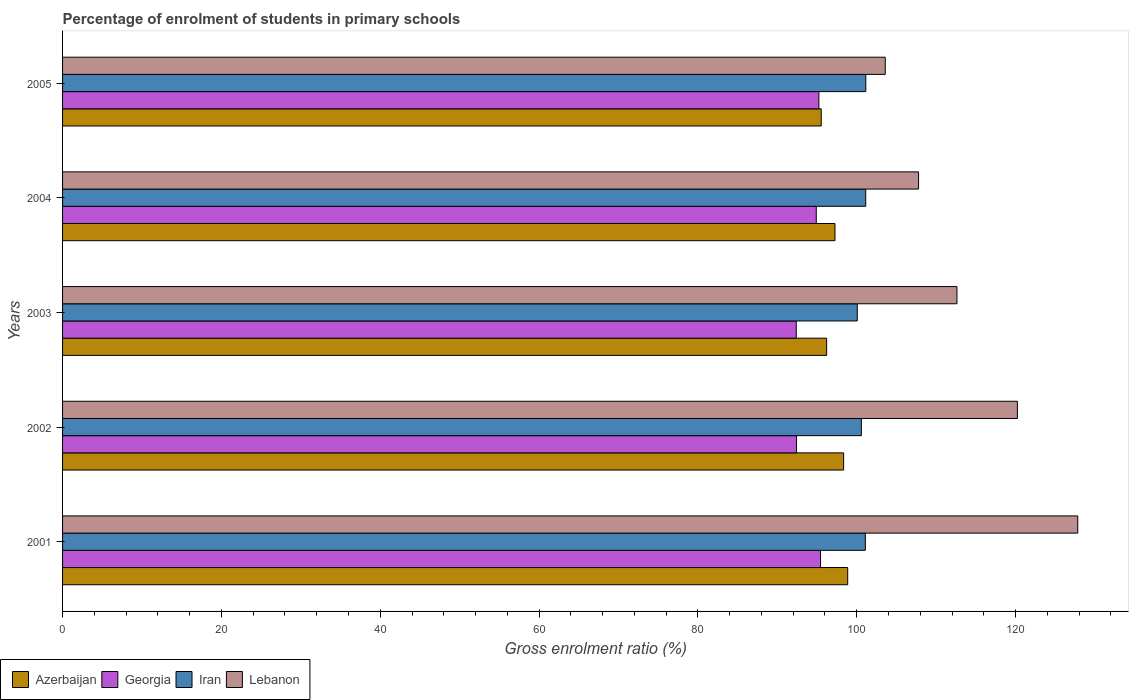How many different coloured bars are there?
Give a very brief answer. 4. Are the number of bars on each tick of the Y-axis equal?
Offer a very short reply. Yes. How many bars are there on the 1st tick from the top?
Make the answer very short. 4. What is the percentage of students enrolled in primary schools in Azerbaijan in 2005?
Your answer should be compact. 95.53. Across all years, what is the maximum percentage of students enrolled in primary schools in Georgia?
Offer a terse response. 95.44. Across all years, what is the minimum percentage of students enrolled in primary schools in Azerbaijan?
Offer a very short reply. 95.53. What is the total percentage of students enrolled in primary schools in Georgia in the graph?
Offer a terse response. 470.38. What is the difference between the percentage of students enrolled in primary schools in Georgia in 2001 and that in 2004?
Offer a very short reply. 0.54. What is the difference between the percentage of students enrolled in primary schools in Lebanon in 2004 and the percentage of students enrolled in primary schools in Georgia in 2001?
Your answer should be very brief. 12.35. What is the average percentage of students enrolled in primary schools in Lebanon per year?
Ensure brevity in your answer.  114.41. In the year 2004, what is the difference between the percentage of students enrolled in primary schools in Lebanon and percentage of students enrolled in primary schools in Iran?
Your answer should be compact. 6.65. What is the ratio of the percentage of students enrolled in primary schools in Iran in 2002 to that in 2004?
Ensure brevity in your answer.  0.99. What is the difference between the highest and the second highest percentage of students enrolled in primary schools in Lebanon?
Offer a terse response. 7.6. What is the difference between the highest and the lowest percentage of students enrolled in primary schools in Georgia?
Make the answer very short. 3.06. In how many years, is the percentage of students enrolled in primary schools in Iran greater than the average percentage of students enrolled in primary schools in Iran taken over all years?
Give a very brief answer. 3. What does the 3rd bar from the top in 2003 represents?
Provide a succinct answer. Georgia. What does the 2nd bar from the bottom in 2002 represents?
Your answer should be compact. Georgia. Is it the case that in every year, the sum of the percentage of students enrolled in primary schools in Lebanon and percentage of students enrolled in primary schools in Azerbaijan is greater than the percentage of students enrolled in primary schools in Georgia?
Your answer should be very brief. Yes. How many bars are there?
Offer a very short reply. 20. What is the difference between two consecutive major ticks on the X-axis?
Offer a terse response. 20. Are the values on the major ticks of X-axis written in scientific E-notation?
Your response must be concise. No. What is the title of the graph?
Give a very brief answer. Percentage of enrolment of students in primary schools. Does "East Asia (developing only)" appear as one of the legend labels in the graph?
Your response must be concise. No. What is the label or title of the Y-axis?
Provide a short and direct response. Years. What is the Gross enrolment ratio (%) of Azerbaijan in 2001?
Make the answer very short. 98.86. What is the Gross enrolment ratio (%) in Georgia in 2001?
Offer a very short reply. 95.44. What is the Gross enrolment ratio (%) in Iran in 2001?
Make the answer very short. 101.08. What is the Gross enrolment ratio (%) in Lebanon in 2001?
Offer a terse response. 127.83. What is the Gross enrolment ratio (%) in Azerbaijan in 2002?
Provide a succinct answer. 98.35. What is the Gross enrolment ratio (%) of Georgia in 2002?
Make the answer very short. 92.42. What is the Gross enrolment ratio (%) in Iran in 2002?
Keep it short and to the point. 100.58. What is the Gross enrolment ratio (%) in Lebanon in 2002?
Your answer should be very brief. 120.23. What is the Gross enrolment ratio (%) of Azerbaijan in 2003?
Offer a terse response. 96.21. What is the Gross enrolment ratio (%) of Georgia in 2003?
Make the answer very short. 92.38. What is the Gross enrolment ratio (%) in Iran in 2003?
Offer a very short reply. 100.07. What is the Gross enrolment ratio (%) in Lebanon in 2003?
Your answer should be compact. 112.62. What is the Gross enrolment ratio (%) in Azerbaijan in 2004?
Provide a succinct answer. 97.26. What is the Gross enrolment ratio (%) of Georgia in 2004?
Your response must be concise. 94.9. What is the Gross enrolment ratio (%) in Iran in 2004?
Offer a terse response. 101.13. What is the Gross enrolment ratio (%) in Lebanon in 2004?
Give a very brief answer. 107.79. What is the Gross enrolment ratio (%) of Azerbaijan in 2005?
Provide a short and direct response. 95.53. What is the Gross enrolment ratio (%) in Georgia in 2005?
Your response must be concise. 95.23. What is the Gross enrolment ratio (%) of Iran in 2005?
Your answer should be compact. 101.14. What is the Gross enrolment ratio (%) of Lebanon in 2005?
Give a very brief answer. 103.59. Across all years, what is the maximum Gross enrolment ratio (%) in Azerbaijan?
Keep it short and to the point. 98.86. Across all years, what is the maximum Gross enrolment ratio (%) of Georgia?
Keep it short and to the point. 95.44. Across all years, what is the maximum Gross enrolment ratio (%) in Iran?
Your answer should be very brief. 101.14. Across all years, what is the maximum Gross enrolment ratio (%) of Lebanon?
Ensure brevity in your answer.  127.83. Across all years, what is the minimum Gross enrolment ratio (%) in Azerbaijan?
Make the answer very short. 95.53. Across all years, what is the minimum Gross enrolment ratio (%) in Georgia?
Offer a terse response. 92.38. Across all years, what is the minimum Gross enrolment ratio (%) of Iran?
Provide a short and direct response. 100.07. Across all years, what is the minimum Gross enrolment ratio (%) in Lebanon?
Ensure brevity in your answer.  103.59. What is the total Gross enrolment ratio (%) in Azerbaijan in the graph?
Make the answer very short. 486.21. What is the total Gross enrolment ratio (%) in Georgia in the graph?
Provide a short and direct response. 470.38. What is the total Gross enrolment ratio (%) of Iran in the graph?
Ensure brevity in your answer.  504.01. What is the total Gross enrolment ratio (%) of Lebanon in the graph?
Give a very brief answer. 572.05. What is the difference between the Gross enrolment ratio (%) in Azerbaijan in 2001 and that in 2002?
Your answer should be very brief. 0.51. What is the difference between the Gross enrolment ratio (%) of Georgia in 2001 and that in 2002?
Your answer should be compact. 3.02. What is the difference between the Gross enrolment ratio (%) in Iran in 2001 and that in 2002?
Your answer should be very brief. 0.5. What is the difference between the Gross enrolment ratio (%) of Lebanon in 2001 and that in 2002?
Offer a terse response. 7.6. What is the difference between the Gross enrolment ratio (%) in Azerbaijan in 2001 and that in 2003?
Give a very brief answer. 2.65. What is the difference between the Gross enrolment ratio (%) in Georgia in 2001 and that in 2003?
Your answer should be very brief. 3.06. What is the difference between the Gross enrolment ratio (%) in Iran in 2001 and that in 2003?
Provide a short and direct response. 1.02. What is the difference between the Gross enrolment ratio (%) in Lebanon in 2001 and that in 2003?
Your answer should be compact. 15.21. What is the difference between the Gross enrolment ratio (%) in Azerbaijan in 2001 and that in 2004?
Your answer should be compact. 1.6. What is the difference between the Gross enrolment ratio (%) in Georgia in 2001 and that in 2004?
Keep it short and to the point. 0.54. What is the difference between the Gross enrolment ratio (%) in Iran in 2001 and that in 2004?
Your answer should be very brief. -0.05. What is the difference between the Gross enrolment ratio (%) in Lebanon in 2001 and that in 2004?
Offer a very short reply. 20.04. What is the difference between the Gross enrolment ratio (%) of Azerbaijan in 2001 and that in 2005?
Provide a short and direct response. 3.33. What is the difference between the Gross enrolment ratio (%) of Georgia in 2001 and that in 2005?
Your answer should be very brief. 0.21. What is the difference between the Gross enrolment ratio (%) of Iran in 2001 and that in 2005?
Offer a terse response. -0.05. What is the difference between the Gross enrolment ratio (%) in Lebanon in 2001 and that in 2005?
Your answer should be very brief. 24.24. What is the difference between the Gross enrolment ratio (%) of Azerbaijan in 2002 and that in 2003?
Your answer should be very brief. 2.14. What is the difference between the Gross enrolment ratio (%) of Georgia in 2002 and that in 2003?
Keep it short and to the point. 0.04. What is the difference between the Gross enrolment ratio (%) of Iran in 2002 and that in 2003?
Keep it short and to the point. 0.51. What is the difference between the Gross enrolment ratio (%) of Lebanon in 2002 and that in 2003?
Your answer should be very brief. 7.61. What is the difference between the Gross enrolment ratio (%) in Azerbaijan in 2002 and that in 2004?
Provide a succinct answer. 1.09. What is the difference between the Gross enrolment ratio (%) of Georgia in 2002 and that in 2004?
Your answer should be very brief. -2.48. What is the difference between the Gross enrolment ratio (%) of Iran in 2002 and that in 2004?
Give a very brief answer. -0.55. What is the difference between the Gross enrolment ratio (%) in Lebanon in 2002 and that in 2004?
Your response must be concise. 12.45. What is the difference between the Gross enrolment ratio (%) in Azerbaijan in 2002 and that in 2005?
Your answer should be compact. 2.82. What is the difference between the Gross enrolment ratio (%) of Georgia in 2002 and that in 2005?
Your response must be concise. -2.81. What is the difference between the Gross enrolment ratio (%) in Iran in 2002 and that in 2005?
Ensure brevity in your answer.  -0.56. What is the difference between the Gross enrolment ratio (%) of Lebanon in 2002 and that in 2005?
Provide a succinct answer. 16.64. What is the difference between the Gross enrolment ratio (%) in Azerbaijan in 2003 and that in 2004?
Your response must be concise. -1.05. What is the difference between the Gross enrolment ratio (%) of Georgia in 2003 and that in 2004?
Your answer should be compact. -2.52. What is the difference between the Gross enrolment ratio (%) in Iran in 2003 and that in 2004?
Your answer should be very brief. -1.06. What is the difference between the Gross enrolment ratio (%) of Lebanon in 2003 and that in 2004?
Keep it short and to the point. 4.83. What is the difference between the Gross enrolment ratio (%) in Azerbaijan in 2003 and that in 2005?
Offer a very short reply. 0.69. What is the difference between the Gross enrolment ratio (%) in Georgia in 2003 and that in 2005?
Keep it short and to the point. -2.85. What is the difference between the Gross enrolment ratio (%) in Iran in 2003 and that in 2005?
Ensure brevity in your answer.  -1.07. What is the difference between the Gross enrolment ratio (%) in Lebanon in 2003 and that in 2005?
Your answer should be compact. 9.03. What is the difference between the Gross enrolment ratio (%) in Azerbaijan in 2004 and that in 2005?
Give a very brief answer. 1.73. What is the difference between the Gross enrolment ratio (%) in Georgia in 2004 and that in 2005?
Make the answer very short. -0.33. What is the difference between the Gross enrolment ratio (%) in Iran in 2004 and that in 2005?
Offer a very short reply. -0.01. What is the difference between the Gross enrolment ratio (%) of Lebanon in 2004 and that in 2005?
Your response must be concise. 4.19. What is the difference between the Gross enrolment ratio (%) in Azerbaijan in 2001 and the Gross enrolment ratio (%) in Georgia in 2002?
Give a very brief answer. 6.44. What is the difference between the Gross enrolment ratio (%) in Azerbaijan in 2001 and the Gross enrolment ratio (%) in Iran in 2002?
Offer a very short reply. -1.72. What is the difference between the Gross enrolment ratio (%) of Azerbaijan in 2001 and the Gross enrolment ratio (%) of Lebanon in 2002?
Ensure brevity in your answer.  -21.37. What is the difference between the Gross enrolment ratio (%) of Georgia in 2001 and the Gross enrolment ratio (%) of Iran in 2002?
Your response must be concise. -5.14. What is the difference between the Gross enrolment ratio (%) of Georgia in 2001 and the Gross enrolment ratio (%) of Lebanon in 2002?
Keep it short and to the point. -24.79. What is the difference between the Gross enrolment ratio (%) of Iran in 2001 and the Gross enrolment ratio (%) of Lebanon in 2002?
Offer a very short reply. -19.15. What is the difference between the Gross enrolment ratio (%) in Azerbaijan in 2001 and the Gross enrolment ratio (%) in Georgia in 2003?
Your response must be concise. 6.48. What is the difference between the Gross enrolment ratio (%) of Azerbaijan in 2001 and the Gross enrolment ratio (%) of Iran in 2003?
Your answer should be very brief. -1.21. What is the difference between the Gross enrolment ratio (%) in Azerbaijan in 2001 and the Gross enrolment ratio (%) in Lebanon in 2003?
Make the answer very short. -13.76. What is the difference between the Gross enrolment ratio (%) of Georgia in 2001 and the Gross enrolment ratio (%) of Iran in 2003?
Your answer should be very brief. -4.63. What is the difference between the Gross enrolment ratio (%) of Georgia in 2001 and the Gross enrolment ratio (%) of Lebanon in 2003?
Keep it short and to the point. -17.18. What is the difference between the Gross enrolment ratio (%) of Iran in 2001 and the Gross enrolment ratio (%) of Lebanon in 2003?
Keep it short and to the point. -11.53. What is the difference between the Gross enrolment ratio (%) in Azerbaijan in 2001 and the Gross enrolment ratio (%) in Georgia in 2004?
Make the answer very short. 3.96. What is the difference between the Gross enrolment ratio (%) in Azerbaijan in 2001 and the Gross enrolment ratio (%) in Iran in 2004?
Ensure brevity in your answer.  -2.27. What is the difference between the Gross enrolment ratio (%) of Azerbaijan in 2001 and the Gross enrolment ratio (%) of Lebanon in 2004?
Offer a very short reply. -8.92. What is the difference between the Gross enrolment ratio (%) in Georgia in 2001 and the Gross enrolment ratio (%) in Iran in 2004?
Provide a succinct answer. -5.69. What is the difference between the Gross enrolment ratio (%) in Georgia in 2001 and the Gross enrolment ratio (%) in Lebanon in 2004?
Your response must be concise. -12.35. What is the difference between the Gross enrolment ratio (%) in Iran in 2001 and the Gross enrolment ratio (%) in Lebanon in 2004?
Make the answer very short. -6.7. What is the difference between the Gross enrolment ratio (%) of Azerbaijan in 2001 and the Gross enrolment ratio (%) of Georgia in 2005?
Give a very brief answer. 3.63. What is the difference between the Gross enrolment ratio (%) of Azerbaijan in 2001 and the Gross enrolment ratio (%) of Iran in 2005?
Ensure brevity in your answer.  -2.28. What is the difference between the Gross enrolment ratio (%) in Azerbaijan in 2001 and the Gross enrolment ratio (%) in Lebanon in 2005?
Provide a succinct answer. -4.73. What is the difference between the Gross enrolment ratio (%) of Georgia in 2001 and the Gross enrolment ratio (%) of Iran in 2005?
Offer a terse response. -5.7. What is the difference between the Gross enrolment ratio (%) of Georgia in 2001 and the Gross enrolment ratio (%) of Lebanon in 2005?
Keep it short and to the point. -8.15. What is the difference between the Gross enrolment ratio (%) of Iran in 2001 and the Gross enrolment ratio (%) of Lebanon in 2005?
Provide a succinct answer. -2.51. What is the difference between the Gross enrolment ratio (%) of Azerbaijan in 2002 and the Gross enrolment ratio (%) of Georgia in 2003?
Offer a very short reply. 5.97. What is the difference between the Gross enrolment ratio (%) of Azerbaijan in 2002 and the Gross enrolment ratio (%) of Iran in 2003?
Make the answer very short. -1.72. What is the difference between the Gross enrolment ratio (%) of Azerbaijan in 2002 and the Gross enrolment ratio (%) of Lebanon in 2003?
Provide a succinct answer. -14.27. What is the difference between the Gross enrolment ratio (%) of Georgia in 2002 and the Gross enrolment ratio (%) of Iran in 2003?
Your answer should be compact. -7.65. What is the difference between the Gross enrolment ratio (%) in Georgia in 2002 and the Gross enrolment ratio (%) in Lebanon in 2003?
Ensure brevity in your answer.  -20.2. What is the difference between the Gross enrolment ratio (%) in Iran in 2002 and the Gross enrolment ratio (%) in Lebanon in 2003?
Provide a succinct answer. -12.04. What is the difference between the Gross enrolment ratio (%) of Azerbaijan in 2002 and the Gross enrolment ratio (%) of Georgia in 2004?
Offer a very short reply. 3.45. What is the difference between the Gross enrolment ratio (%) of Azerbaijan in 2002 and the Gross enrolment ratio (%) of Iran in 2004?
Your answer should be compact. -2.78. What is the difference between the Gross enrolment ratio (%) in Azerbaijan in 2002 and the Gross enrolment ratio (%) in Lebanon in 2004?
Ensure brevity in your answer.  -9.44. What is the difference between the Gross enrolment ratio (%) in Georgia in 2002 and the Gross enrolment ratio (%) in Iran in 2004?
Give a very brief answer. -8.71. What is the difference between the Gross enrolment ratio (%) in Georgia in 2002 and the Gross enrolment ratio (%) in Lebanon in 2004?
Offer a terse response. -15.37. What is the difference between the Gross enrolment ratio (%) in Iran in 2002 and the Gross enrolment ratio (%) in Lebanon in 2004?
Offer a terse response. -7.2. What is the difference between the Gross enrolment ratio (%) of Azerbaijan in 2002 and the Gross enrolment ratio (%) of Georgia in 2005?
Ensure brevity in your answer.  3.12. What is the difference between the Gross enrolment ratio (%) in Azerbaijan in 2002 and the Gross enrolment ratio (%) in Iran in 2005?
Offer a terse response. -2.79. What is the difference between the Gross enrolment ratio (%) of Azerbaijan in 2002 and the Gross enrolment ratio (%) of Lebanon in 2005?
Make the answer very short. -5.24. What is the difference between the Gross enrolment ratio (%) in Georgia in 2002 and the Gross enrolment ratio (%) in Iran in 2005?
Your answer should be very brief. -8.72. What is the difference between the Gross enrolment ratio (%) in Georgia in 2002 and the Gross enrolment ratio (%) in Lebanon in 2005?
Offer a very short reply. -11.17. What is the difference between the Gross enrolment ratio (%) in Iran in 2002 and the Gross enrolment ratio (%) in Lebanon in 2005?
Offer a terse response. -3.01. What is the difference between the Gross enrolment ratio (%) in Azerbaijan in 2003 and the Gross enrolment ratio (%) in Georgia in 2004?
Your answer should be compact. 1.31. What is the difference between the Gross enrolment ratio (%) in Azerbaijan in 2003 and the Gross enrolment ratio (%) in Iran in 2004?
Offer a very short reply. -4.92. What is the difference between the Gross enrolment ratio (%) of Azerbaijan in 2003 and the Gross enrolment ratio (%) of Lebanon in 2004?
Make the answer very short. -11.57. What is the difference between the Gross enrolment ratio (%) of Georgia in 2003 and the Gross enrolment ratio (%) of Iran in 2004?
Make the answer very short. -8.75. What is the difference between the Gross enrolment ratio (%) in Georgia in 2003 and the Gross enrolment ratio (%) in Lebanon in 2004?
Provide a short and direct response. -15.4. What is the difference between the Gross enrolment ratio (%) of Iran in 2003 and the Gross enrolment ratio (%) of Lebanon in 2004?
Provide a succinct answer. -7.72. What is the difference between the Gross enrolment ratio (%) of Azerbaijan in 2003 and the Gross enrolment ratio (%) of Iran in 2005?
Ensure brevity in your answer.  -4.93. What is the difference between the Gross enrolment ratio (%) in Azerbaijan in 2003 and the Gross enrolment ratio (%) in Lebanon in 2005?
Your answer should be compact. -7.38. What is the difference between the Gross enrolment ratio (%) in Georgia in 2003 and the Gross enrolment ratio (%) in Iran in 2005?
Your answer should be compact. -8.76. What is the difference between the Gross enrolment ratio (%) in Georgia in 2003 and the Gross enrolment ratio (%) in Lebanon in 2005?
Your response must be concise. -11.21. What is the difference between the Gross enrolment ratio (%) in Iran in 2003 and the Gross enrolment ratio (%) in Lebanon in 2005?
Keep it short and to the point. -3.52. What is the difference between the Gross enrolment ratio (%) in Azerbaijan in 2004 and the Gross enrolment ratio (%) in Georgia in 2005?
Provide a short and direct response. 2.03. What is the difference between the Gross enrolment ratio (%) in Azerbaijan in 2004 and the Gross enrolment ratio (%) in Iran in 2005?
Your answer should be compact. -3.88. What is the difference between the Gross enrolment ratio (%) in Azerbaijan in 2004 and the Gross enrolment ratio (%) in Lebanon in 2005?
Offer a very short reply. -6.33. What is the difference between the Gross enrolment ratio (%) of Georgia in 2004 and the Gross enrolment ratio (%) of Iran in 2005?
Your response must be concise. -6.24. What is the difference between the Gross enrolment ratio (%) in Georgia in 2004 and the Gross enrolment ratio (%) in Lebanon in 2005?
Offer a terse response. -8.69. What is the difference between the Gross enrolment ratio (%) of Iran in 2004 and the Gross enrolment ratio (%) of Lebanon in 2005?
Your response must be concise. -2.46. What is the average Gross enrolment ratio (%) in Azerbaijan per year?
Offer a very short reply. 97.24. What is the average Gross enrolment ratio (%) of Georgia per year?
Provide a succinct answer. 94.08. What is the average Gross enrolment ratio (%) in Iran per year?
Give a very brief answer. 100.8. What is the average Gross enrolment ratio (%) in Lebanon per year?
Ensure brevity in your answer.  114.41. In the year 2001, what is the difference between the Gross enrolment ratio (%) in Azerbaijan and Gross enrolment ratio (%) in Georgia?
Give a very brief answer. 3.42. In the year 2001, what is the difference between the Gross enrolment ratio (%) in Azerbaijan and Gross enrolment ratio (%) in Iran?
Give a very brief answer. -2.22. In the year 2001, what is the difference between the Gross enrolment ratio (%) of Azerbaijan and Gross enrolment ratio (%) of Lebanon?
Give a very brief answer. -28.97. In the year 2001, what is the difference between the Gross enrolment ratio (%) in Georgia and Gross enrolment ratio (%) in Iran?
Your response must be concise. -5.65. In the year 2001, what is the difference between the Gross enrolment ratio (%) of Georgia and Gross enrolment ratio (%) of Lebanon?
Provide a succinct answer. -32.39. In the year 2001, what is the difference between the Gross enrolment ratio (%) in Iran and Gross enrolment ratio (%) in Lebanon?
Provide a short and direct response. -26.74. In the year 2002, what is the difference between the Gross enrolment ratio (%) of Azerbaijan and Gross enrolment ratio (%) of Georgia?
Offer a terse response. 5.93. In the year 2002, what is the difference between the Gross enrolment ratio (%) of Azerbaijan and Gross enrolment ratio (%) of Iran?
Offer a very short reply. -2.23. In the year 2002, what is the difference between the Gross enrolment ratio (%) of Azerbaijan and Gross enrolment ratio (%) of Lebanon?
Keep it short and to the point. -21.88. In the year 2002, what is the difference between the Gross enrolment ratio (%) in Georgia and Gross enrolment ratio (%) in Iran?
Provide a short and direct response. -8.16. In the year 2002, what is the difference between the Gross enrolment ratio (%) in Georgia and Gross enrolment ratio (%) in Lebanon?
Offer a very short reply. -27.81. In the year 2002, what is the difference between the Gross enrolment ratio (%) of Iran and Gross enrolment ratio (%) of Lebanon?
Give a very brief answer. -19.65. In the year 2003, what is the difference between the Gross enrolment ratio (%) in Azerbaijan and Gross enrolment ratio (%) in Georgia?
Make the answer very short. 3.83. In the year 2003, what is the difference between the Gross enrolment ratio (%) in Azerbaijan and Gross enrolment ratio (%) in Iran?
Make the answer very short. -3.86. In the year 2003, what is the difference between the Gross enrolment ratio (%) of Azerbaijan and Gross enrolment ratio (%) of Lebanon?
Your answer should be very brief. -16.41. In the year 2003, what is the difference between the Gross enrolment ratio (%) of Georgia and Gross enrolment ratio (%) of Iran?
Your response must be concise. -7.69. In the year 2003, what is the difference between the Gross enrolment ratio (%) of Georgia and Gross enrolment ratio (%) of Lebanon?
Ensure brevity in your answer.  -20.24. In the year 2003, what is the difference between the Gross enrolment ratio (%) in Iran and Gross enrolment ratio (%) in Lebanon?
Keep it short and to the point. -12.55. In the year 2004, what is the difference between the Gross enrolment ratio (%) in Azerbaijan and Gross enrolment ratio (%) in Georgia?
Offer a terse response. 2.36. In the year 2004, what is the difference between the Gross enrolment ratio (%) in Azerbaijan and Gross enrolment ratio (%) in Iran?
Keep it short and to the point. -3.87. In the year 2004, what is the difference between the Gross enrolment ratio (%) of Azerbaijan and Gross enrolment ratio (%) of Lebanon?
Provide a short and direct response. -10.52. In the year 2004, what is the difference between the Gross enrolment ratio (%) of Georgia and Gross enrolment ratio (%) of Iran?
Your response must be concise. -6.23. In the year 2004, what is the difference between the Gross enrolment ratio (%) in Georgia and Gross enrolment ratio (%) in Lebanon?
Offer a very short reply. -12.88. In the year 2004, what is the difference between the Gross enrolment ratio (%) in Iran and Gross enrolment ratio (%) in Lebanon?
Offer a very short reply. -6.65. In the year 2005, what is the difference between the Gross enrolment ratio (%) in Azerbaijan and Gross enrolment ratio (%) in Georgia?
Your answer should be compact. 0.29. In the year 2005, what is the difference between the Gross enrolment ratio (%) of Azerbaijan and Gross enrolment ratio (%) of Iran?
Offer a very short reply. -5.61. In the year 2005, what is the difference between the Gross enrolment ratio (%) of Azerbaijan and Gross enrolment ratio (%) of Lebanon?
Give a very brief answer. -8.06. In the year 2005, what is the difference between the Gross enrolment ratio (%) of Georgia and Gross enrolment ratio (%) of Iran?
Keep it short and to the point. -5.91. In the year 2005, what is the difference between the Gross enrolment ratio (%) in Georgia and Gross enrolment ratio (%) in Lebanon?
Keep it short and to the point. -8.36. In the year 2005, what is the difference between the Gross enrolment ratio (%) of Iran and Gross enrolment ratio (%) of Lebanon?
Offer a very short reply. -2.45. What is the ratio of the Gross enrolment ratio (%) in Azerbaijan in 2001 to that in 2002?
Ensure brevity in your answer.  1.01. What is the ratio of the Gross enrolment ratio (%) of Georgia in 2001 to that in 2002?
Ensure brevity in your answer.  1.03. What is the ratio of the Gross enrolment ratio (%) of Iran in 2001 to that in 2002?
Give a very brief answer. 1. What is the ratio of the Gross enrolment ratio (%) of Lebanon in 2001 to that in 2002?
Give a very brief answer. 1.06. What is the ratio of the Gross enrolment ratio (%) of Azerbaijan in 2001 to that in 2003?
Give a very brief answer. 1.03. What is the ratio of the Gross enrolment ratio (%) in Georgia in 2001 to that in 2003?
Provide a succinct answer. 1.03. What is the ratio of the Gross enrolment ratio (%) of Iran in 2001 to that in 2003?
Provide a succinct answer. 1.01. What is the ratio of the Gross enrolment ratio (%) of Lebanon in 2001 to that in 2003?
Offer a terse response. 1.14. What is the ratio of the Gross enrolment ratio (%) in Azerbaijan in 2001 to that in 2004?
Your response must be concise. 1.02. What is the ratio of the Gross enrolment ratio (%) of Georgia in 2001 to that in 2004?
Make the answer very short. 1.01. What is the ratio of the Gross enrolment ratio (%) of Iran in 2001 to that in 2004?
Keep it short and to the point. 1. What is the ratio of the Gross enrolment ratio (%) of Lebanon in 2001 to that in 2004?
Give a very brief answer. 1.19. What is the ratio of the Gross enrolment ratio (%) of Azerbaijan in 2001 to that in 2005?
Offer a very short reply. 1.03. What is the ratio of the Gross enrolment ratio (%) of Lebanon in 2001 to that in 2005?
Provide a short and direct response. 1.23. What is the ratio of the Gross enrolment ratio (%) of Azerbaijan in 2002 to that in 2003?
Keep it short and to the point. 1.02. What is the ratio of the Gross enrolment ratio (%) in Iran in 2002 to that in 2003?
Offer a terse response. 1.01. What is the ratio of the Gross enrolment ratio (%) of Lebanon in 2002 to that in 2003?
Give a very brief answer. 1.07. What is the ratio of the Gross enrolment ratio (%) of Azerbaijan in 2002 to that in 2004?
Offer a terse response. 1.01. What is the ratio of the Gross enrolment ratio (%) of Georgia in 2002 to that in 2004?
Your answer should be compact. 0.97. What is the ratio of the Gross enrolment ratio (%) of Lebanon in 2002 to that in 2004?
Offer a very short reply. 1.12. What is the ratio of the Gross enrolment ratio (%) of Azerbaijan in 2002 to that in 2005?
Give a very brief answer. 1.03. What is the ratio of the Gross enrolment ratio (%) in Georgia in 2002 to that in 2005?
Offer a terse response. 0.97. What is the ratio of the Gross enrolment ratio (%) in Lebanon in 2002 to that in 2005?
Offer a terse response. 1.16. What is the ratio of the Gross enrolment ratio (%) in Azerbaijan in 2003 to that in 2004?
Keep it short and to the point. 0.99. What is the ratio of the Gross enrolment ratio (%) of Georgia in 2003 to that in 2004?
Ensure brevity in your answer.  0.97. What is the ratio of the Gross enrolment ratio (%) of Iran in 2003 to that in 2004?
Provide a short and direct response. 0.99. What is the ratio of the Gross enrolment ratio (%) of Lebanon in 2003 to that in 2004?
Your answer should be compact. 1.04. What is the ratio of the Gross enrolment ratio (%) of Azerbaijan in 2003 to that in 2005?
Offer a terse response. 1.01. What is the ratio of the Gross enrolment ratio (%) in Georgia in 2003 to that in 2005?
Ensure brevity in your answer.  0.97. What is the ratio of the Gross enrolment ratio (%) in Iran in 2003 to that in 2005?
Offer a terse response. 0.99. What is the ratio of the Gross enrolment ratio (%) of Lebanon in 2003 to that in 2005?
Ensure brevity in your answer.  1.09. What is the ratio of the Gross enrolment ratio (%) of Azerbaijan in 2004 to that in 2005?
Offer a very short reply. 1.02. What is the ratio of the Gross enrolment ratio (%) of Georgia in 2004 to that in 2005?
Your answer should be very brief. 1. What is the ratio of the Gross enrolment ratio (%) in Iran in 2004 to that in 2005?
Provide a succinct answer. 1. What is the ratio of the Gross enrolment ratio (%) of Lebanon in 2004 to that in 2005?
Give a very brief answer. 1.04. What is the difference between the highest and the second highest Gross enrolment ratio (%) in Azerbaijan?
Your answer should be very brief. 0.51. What is the difference between the highest and the second highest Gross enrolment ratio (%) in Georgia?
Provide a succinct answer. 0.21. What is the difference between the highest and the second highest Gross enrolment ratio (%) of Iran?
Your answer should be compact. 0.01. What is the difference between the highest and the second highest Gross enrolment ratio (%) in Lebanon?
Your answer should be compact. 7.6. What is the difference between the highest and the lowest Gross enrolment ratio (%) of Azerbaijan?
Keep it short and to the point. 3.33. What is the difference between the highest and the lowest Gross enrolment ratio (%) in Georgia?
Give a very brief answer. 3.06. What is the difference between the highest and the lowest Gross enrolment ratio (%) in Iran?
Make the answer very short. 1.07. What is the difference between the highest and the lowest Gross enrolment ratio (%) in Lebanon?
Offer a very short reply. 24.24. 